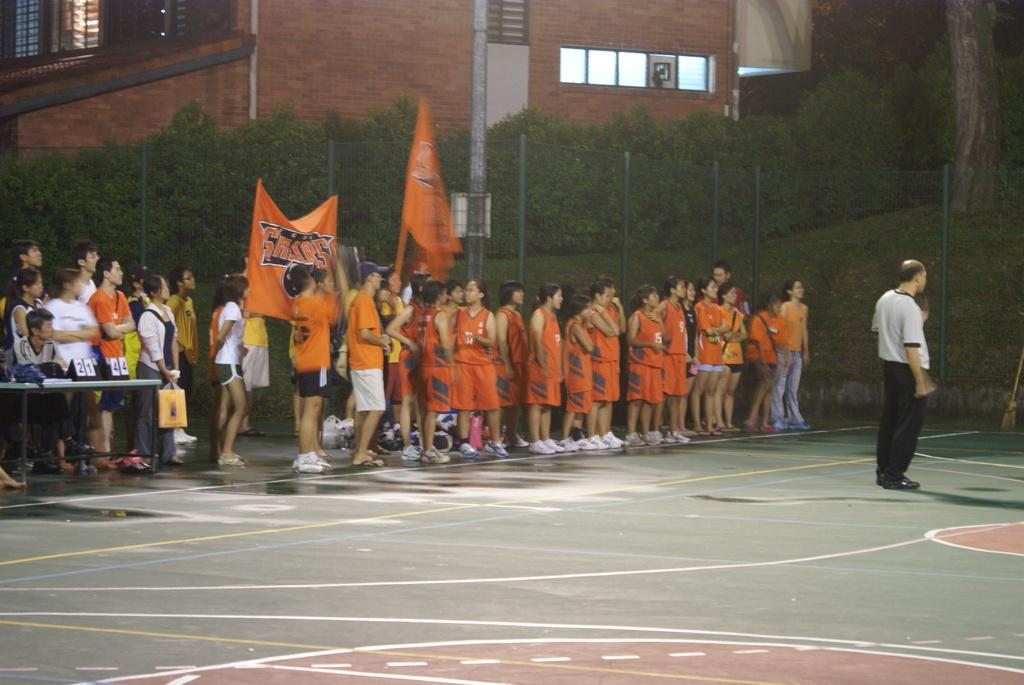What is happening on the road in the image? There is a crowd standing on the road in the image. What time of day is the image taken? The image is taken during night. What can be seen in the background of the image? There are posters, trees, a fence, a building, and windows visible in the background. How many quarters does the son have in the image? There is no woman or son present in the image, and therefore no quarters can be associated with them. 